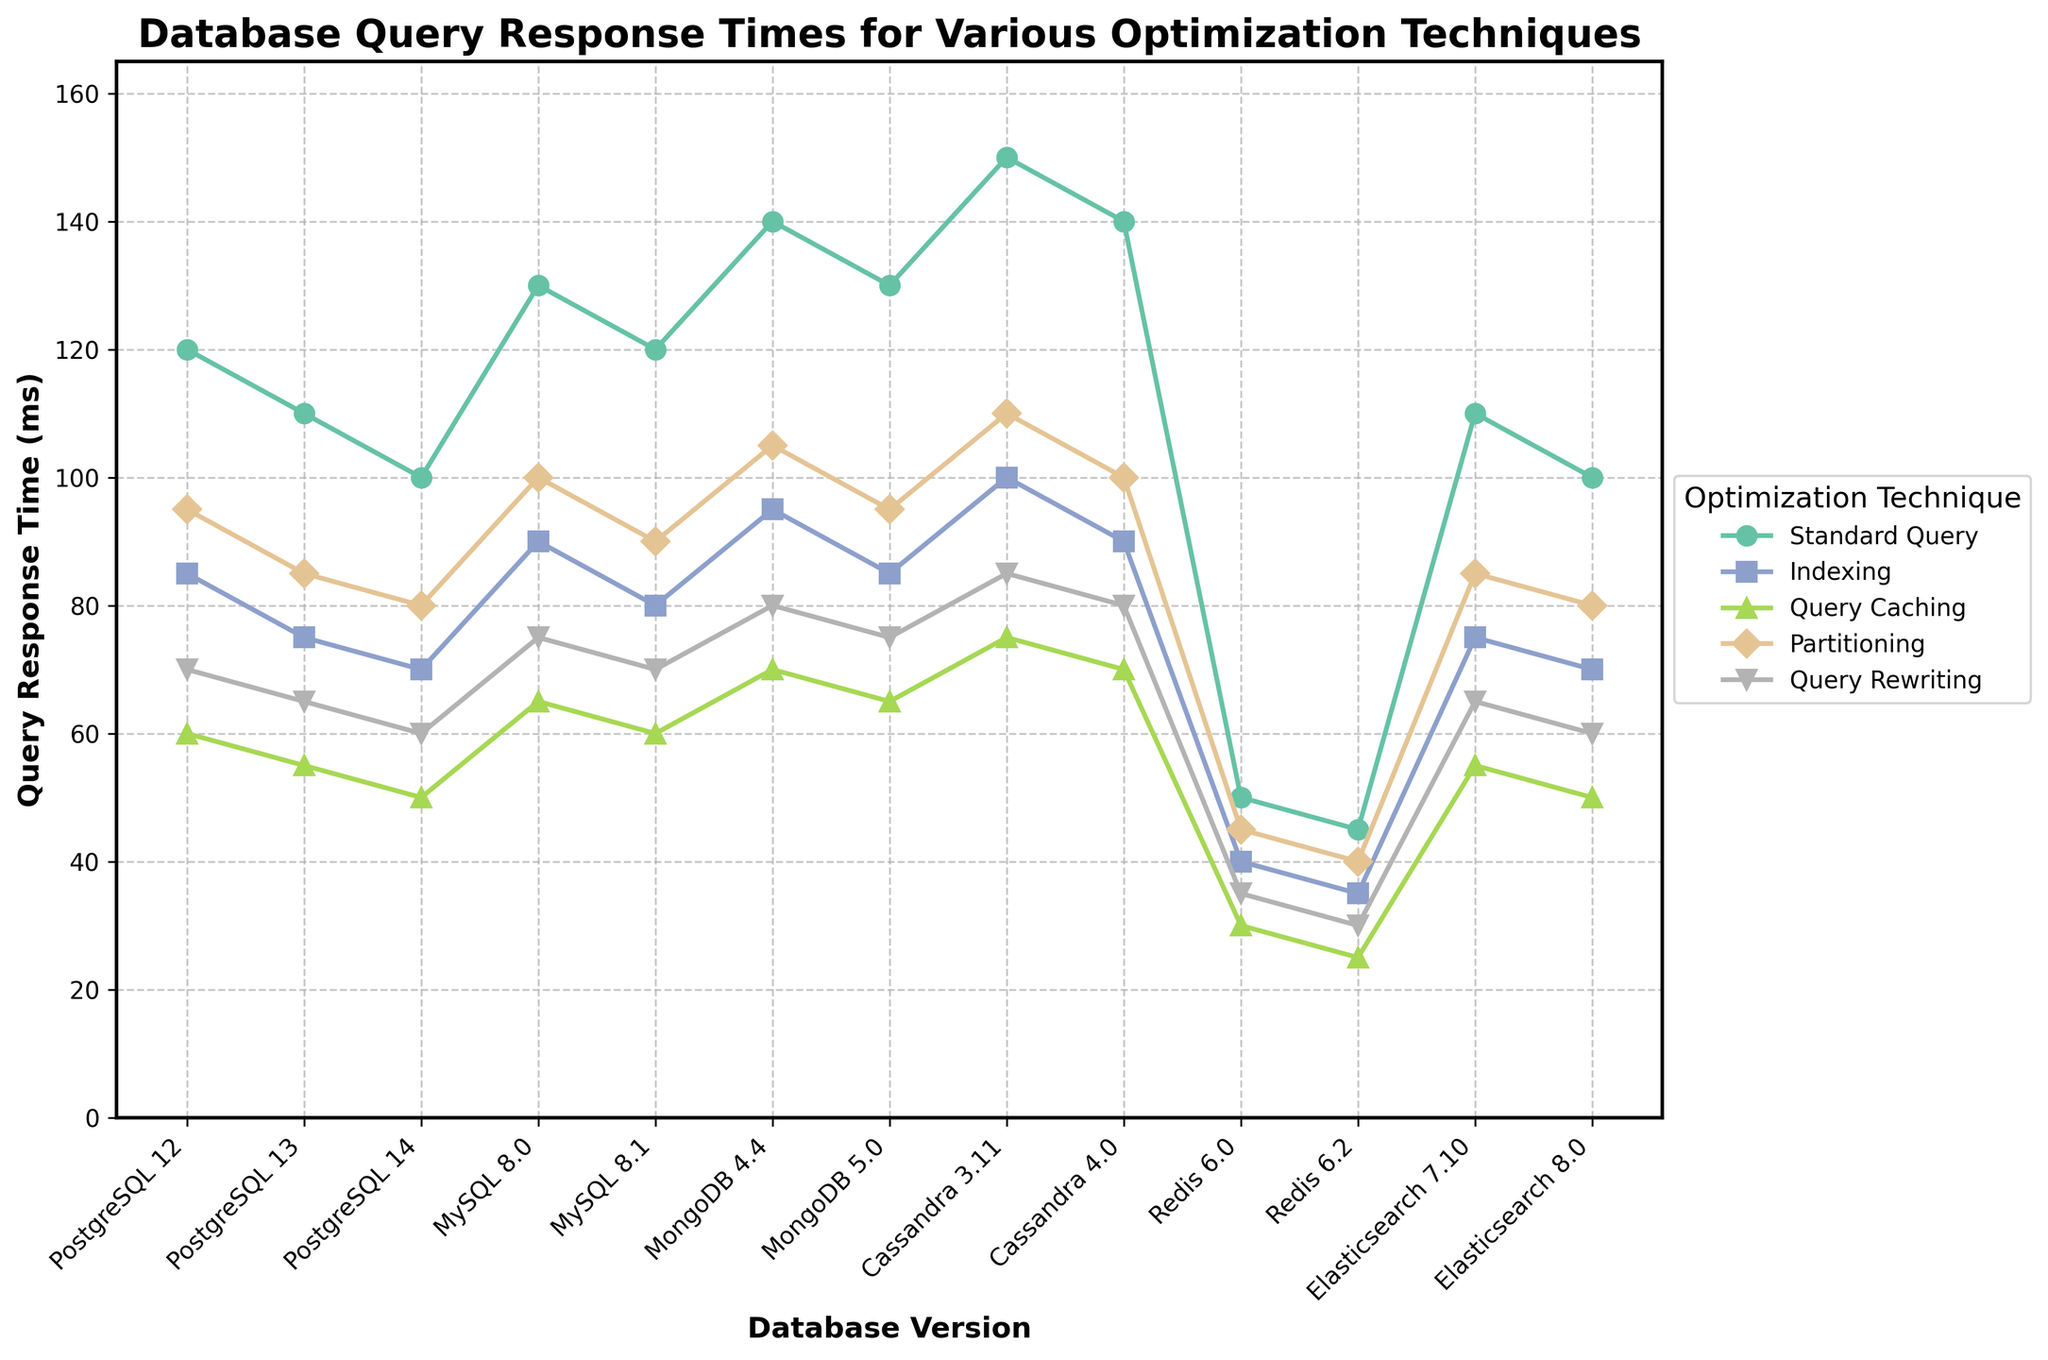Which optimization technique shows the lowest query response time for PostgreSQL 14? First, look at the data points corresponding to PostgreSQL 14 for each optimization technique. The values are Standard Query (100), Indexing (70), Query Caching (50), Partitioning (80), Query Rewriting (60). The lowest value is 50 for Query Caching.
Answer: Query Caching How does the query response time for Indexing in MongoDB 5.0 compare to MySQL 8.1? Look at the data points for Indexing in MongoDB 5.0 (85 ms) and MySQL 8.1 (80 ms). Compare these values: 85 ms > 80 ms. Therefore, MongoDB 5.0 has a higher response time for Indexing than MySQL 8.1.
Answer: MongoDB 5.0 is higher Which database version and technique combination has the highest query response time in the figure? Examine all the data points to find the maximum query response time value. The highest value in the entire figure is 150 for Standard Query in Cassandra 3.11.
Answer: Cassandra 3.11, Standard Query What is the average query response time for all optimization techniques in Redis 6.2? Retrieve the data points for Redis 6.2: Standard Query (45), Indexing (35), Query Caching (25), Partitioning (40), Query Rewriting (30). Calculate the average: (45 + 35 + 25 + 40 + 30) / 5 = 175 / 5 = 35.
Answer: 35 ms Compare the query response time for Partitioning between PostgreSQL 13 and Elasticsearch 7.10. Retrieve the data points: PostgreSQL 13 (85 ms) and Elasticsearch 7.10 (85 ms). Both values are equal.
Answer: Equal Which optimization technique shows the greatest improvement in query response time between PostgreSQL 12 and PostgreSQL 13? Calculate the difference in response times for each technique: Standard Query (120 - 110 = 10), Indexing (85 - 75 = 10), Query Caching (60 - 55 = 5), Partitioning (95 - 85 = 10), Query Rewriting (70 - 65 = 5). Several techniques show a 10 ms improvement, but Indexing is one of them.
Answer: Indexing (and others with equal improvement) What is the overall trend in query response times for Standard Query across PostgreSQL versions 12, 13, and 14? Look at the data points for Standard Query across PostgreSQL 12 (120), PostgreSQL 13 (110), PostgreSQL 14 (100). The values show a consistent decrease over the versions.
Answer: Decreasing trend How does the query response time for Query Caching in MongoDB 4.4 compare to Redis 6.2 visually on the plot? Look at the Query Caching data points for MongoDB 4.4 (70) and Redis 6.2 (25). Visually compare the height differences in the plot. MongoDB 4.4 has a visibly taller data point for Query Caching compared to Redis 6.2.
Answer: MongoDB 4.4 is higher Is there any optimization technique where Cassandra 4.0 performs better than PostgreSQL 14? Compare the values for all techniques: Standard Query (140 vs. 100), Indexing (90 vs. 70), Query Caching (70 vs. 50), Partitioning (100 vs. 80), Query Rewriting (80 vs. 60). PostgreSQL 14 outperforms Cassandra 4.0 in all techniques.
Answer: No What is the change in query response time for the Standard Query technique from MySQL 8.0 to MySQL 8.1? Retrieve the data: MySQL 8.0 (130), MySQL 8.1 (120). Calculate the change: 130 - 120 = 10 ms decrease.
Answer: 10 ms decrease 